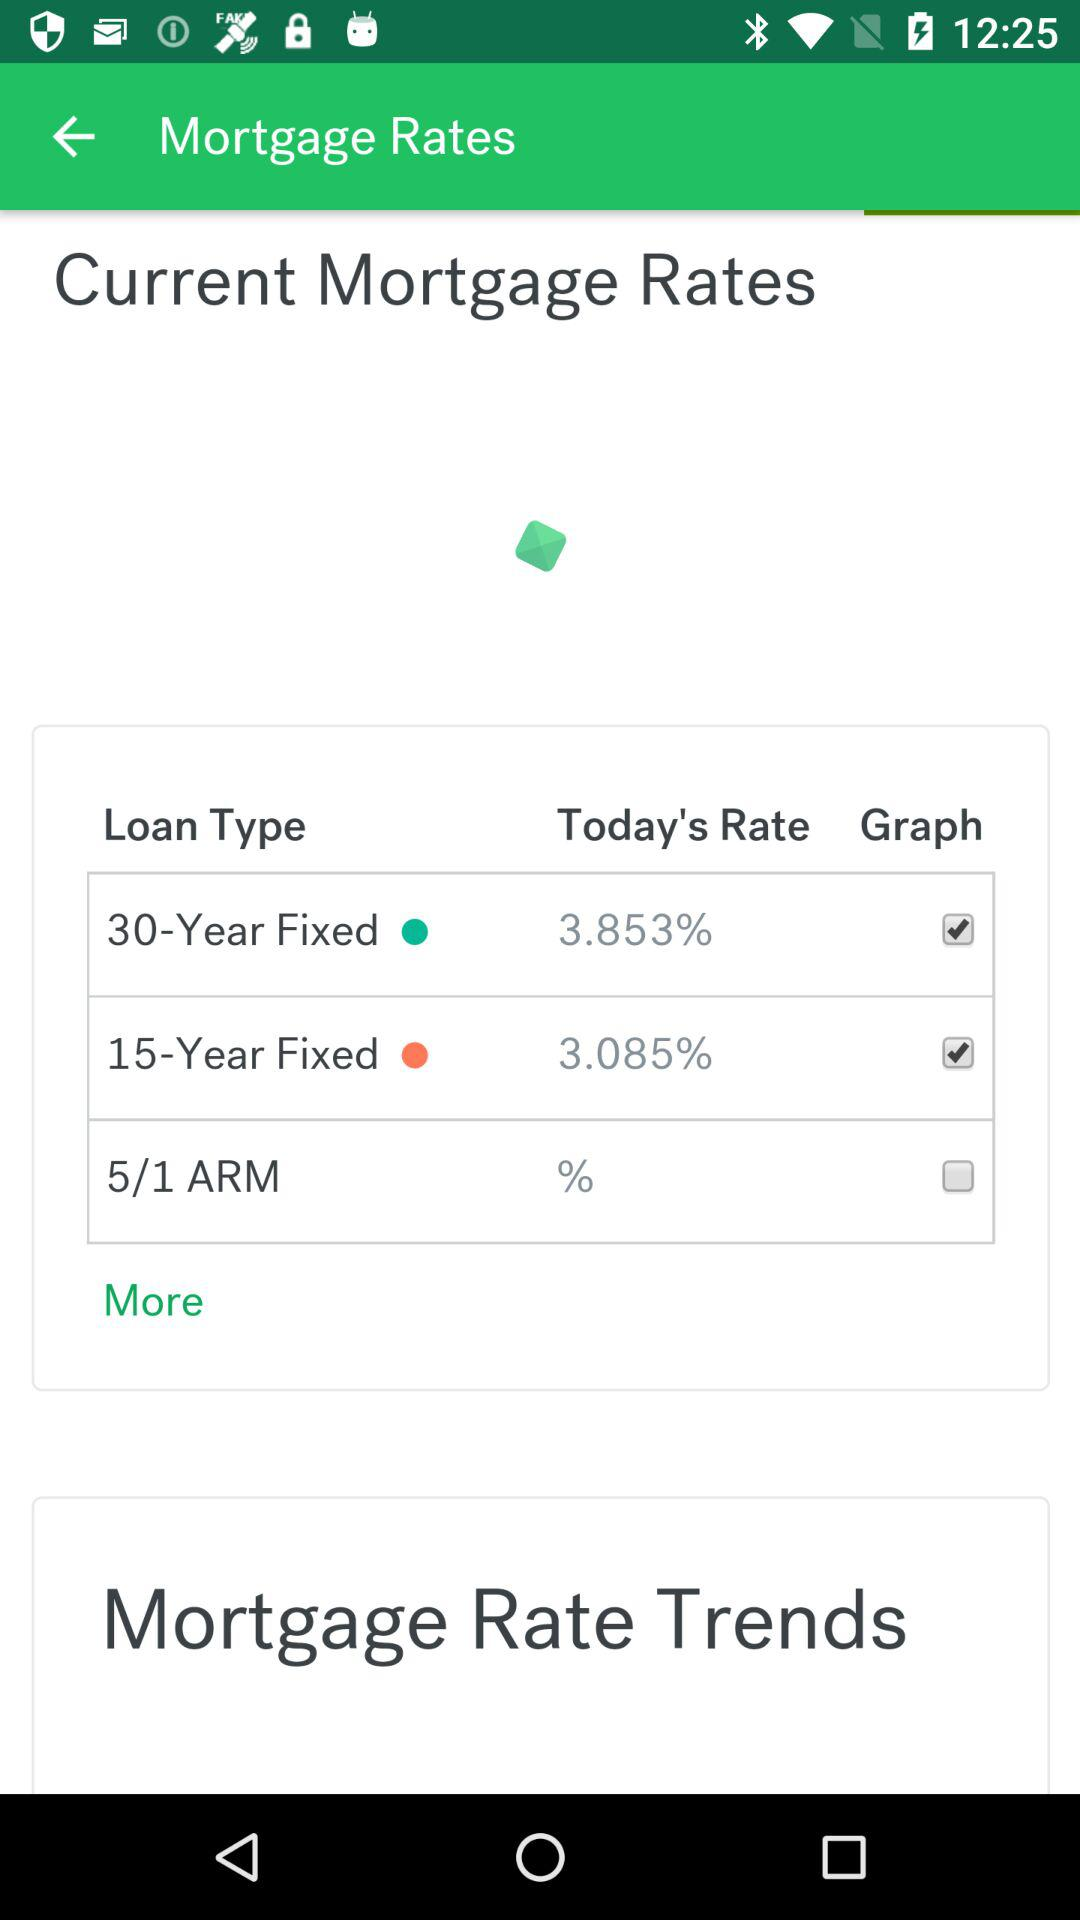What is today's rate of the 15-Year Fixed loan type?
Answer the question using a single word or phrase. It is 3.085%. 